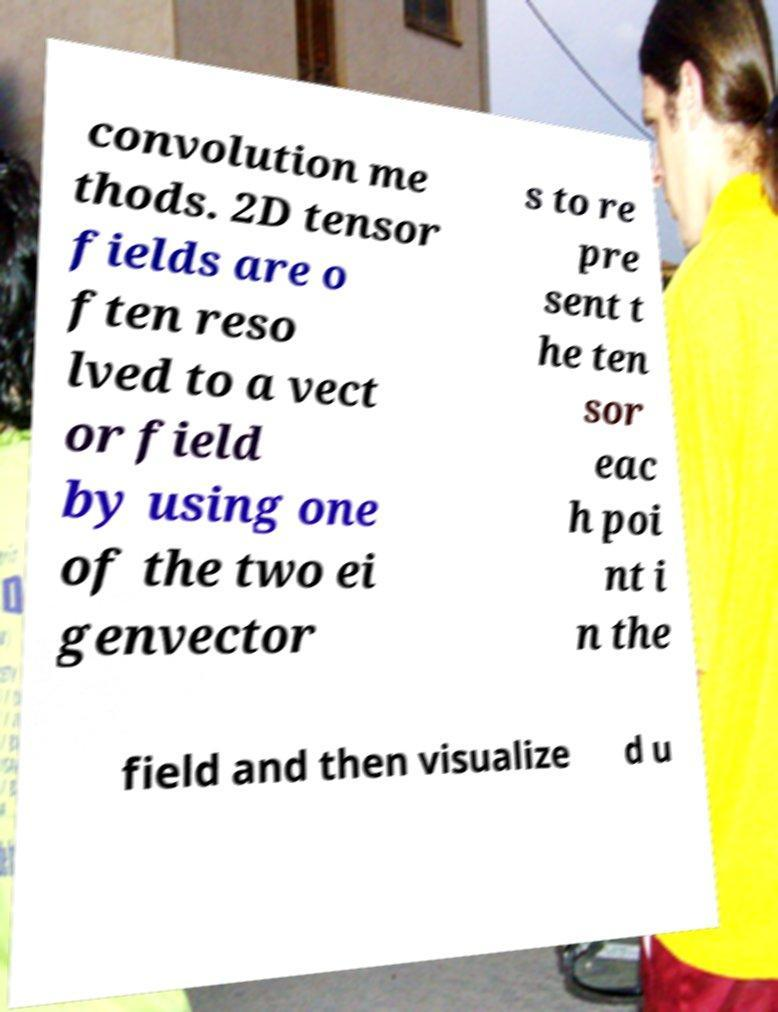Can you read and provide the text displayed in the image?This photo seems to have some interesting text. Can you extract and type it out for me? convolution me thods. 2D tensor fields are o ften reso lved to a vect or field by using one of the two ei genvector s to re pre sent t he ten sor eac h poi nt i n the field and then visualize d u 